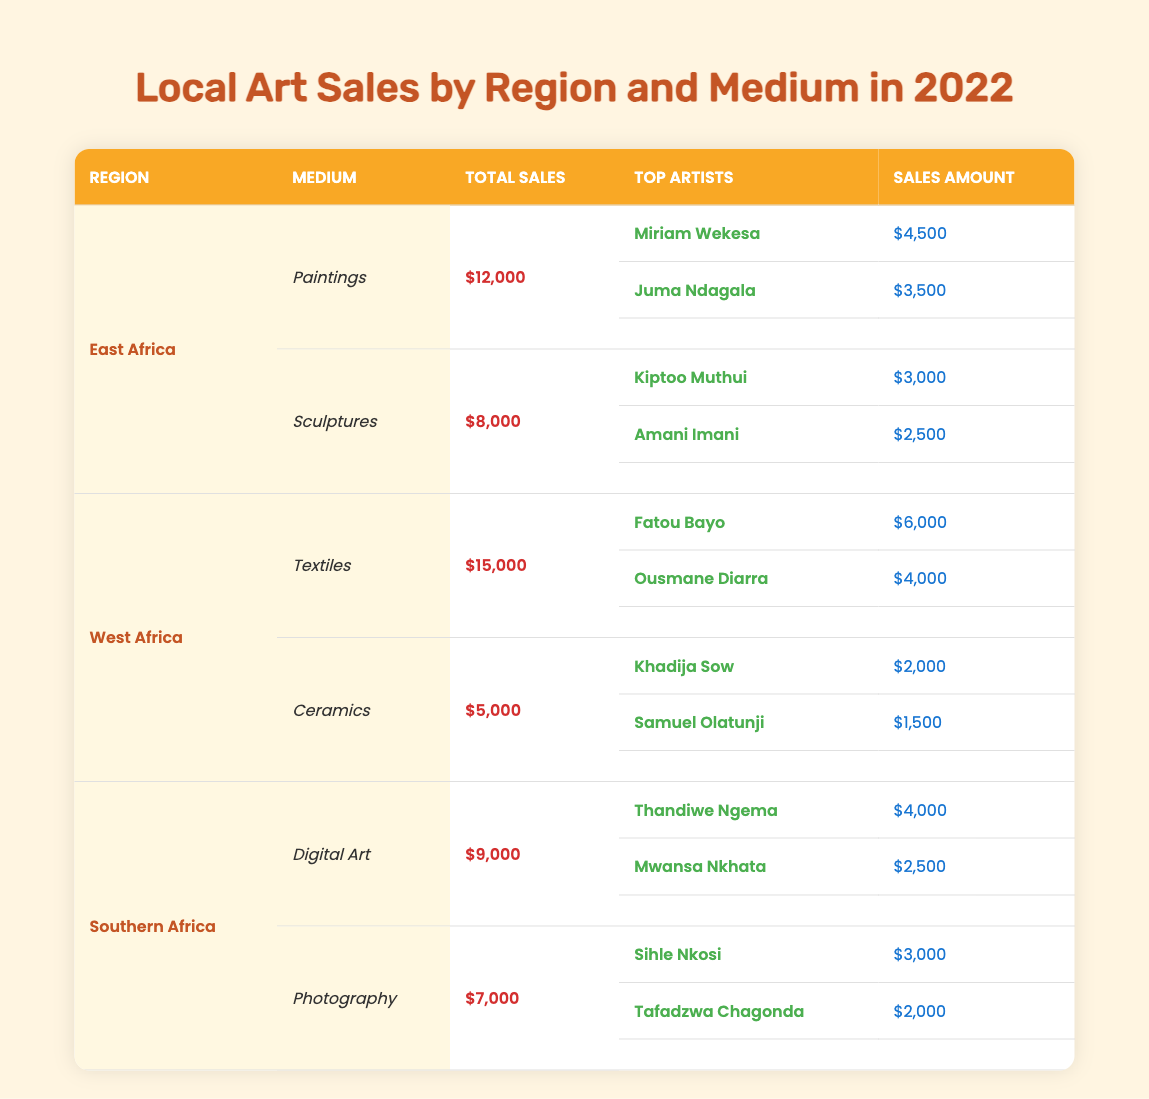What are the total sales for Digital Art in Southern Africa? From the table, the section for Southern Africa indicates that the total sales for Digital Art are listed as $9,000.
Answer: $9,000 Who is the top-selling artist for Textiles in West Africa? In the West Africa section under Textiles, the top artist is Fatou Bayo with sales amounting to $6,000.
Answer: Fatou Bayo Which medium had the highest total sales in East Africa? Reviewing the total sales for both Paintings ($12,000) and Sculptures ($8,000) in East Africa, Paintings have the highest total sales at $12,000.
Answer: Paintings Is it true that the total sales for Ceramics in West Africa exceeded $5,000? The table states that the total sales for Ceramics in West Africa are exactly $5,000, so it does not exceed this amount.
Answer: No What is the combined sales amount for the top artists in Photography from Southern Africa? The top artists in Photography are Sihle Nkosi ($3,000) and Tafadzwa Chagonda ($2,000). Adding their sales gives $3,000 + $2,000 = $5,000.
Answer: $5,000 How much more did the top artist in Textiles earn than the top artist in Ceramics? For Textiles, the top artist Fatou Bayo earned $6,000, while for Ceramics, Khadija Sow earned $2,000. The difference is $6,000 - $2,000 = $4,000.
Answer: $4,000 What is the average sales amount for the top artists in Sculptures from East Africa? The top artists in Sculptures are Kiptoo Muthui ($3,000) and Amani Imani ($2,500). Their combined sales amount is $3,000 + $2,500 = $5,500. The average is $5,500 / 2 = $2,750.
Answer: $2,750 Who had higher earnings, Juma Ndagala from East Africa or Ousmane Diarra from West Africa? Juma Ndagala earned $3,500 in East Africa, while Ousmane Diarra earned $4,000 in West Africa. Since $4,000 is greater than $3,500, Ousmane Diarra had higher earnings.
Answer: Ousmane Diarra In which region did Digital Art and Photography together generate more total sales: Southern Africa or East Africa? Southern Africa generated $9,000 from Digital Art and $7,000 from Photography, totaling $16,000. In East Africa, the totals for Paintings and Sculptures combined are $12,000 + $8,000 = $20,000. Since $20,000 (East Africa) is greater than $16,000 (Southern Africa), East Africa generated more total sales.
Answer: East Africa 